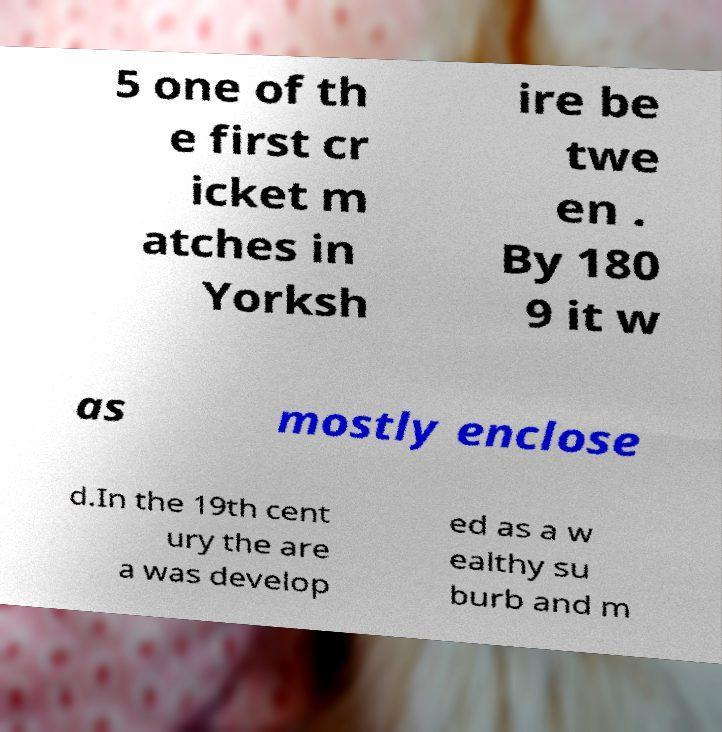I need the written content from this picture converted into text. Can you do that? 5 one of th e first cr icket m atches in Yorksh ire be twe en . By 180 9 it w as mostly enclose d.In the 19th cent ury the are a was develop ed as a w ealthy su burb and m 